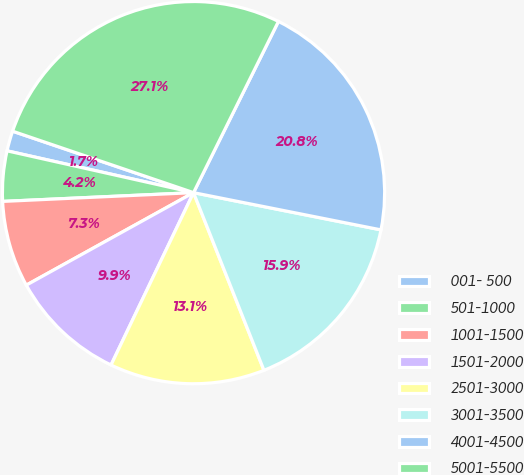Convert chart. <chart><loc_0><loc_0><loc_500><loc_500><pie_chart><fcel>001- 500<fcel>501-1000<fcel>1001-1500<fcel>1501-2000<fcel>2501-3000<fcel>3001-3500<fcel>4001-4500<fcel>5001-5500<nl><fcel>1.7%<fcel>4.24%<fcel>7.31%<fcel>9.85%<fcel>13.11%<fcel>15.87%<fcel>20.79%<fcel>27.11%<nl></chart> 